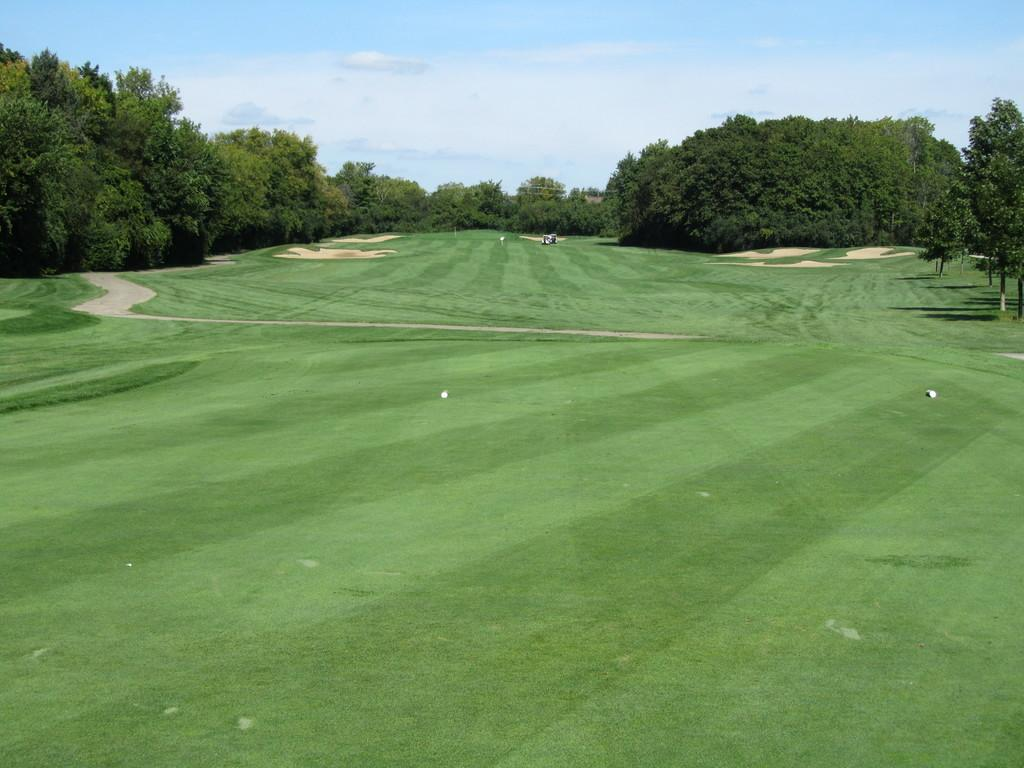What is the primary surface visible in the image? There is a ground in the image. What can be found on the ground in the image? There are objects on the ground. What is the central feature of the image? There is a lane in the center of the image. What type of vegetation is visible at the top of the image? There are trees visible at the top of the image. What is visible above the trees in the image? The sky is visible at the top of the image. What can be seen in the sky in the image? Clouds are present in the sky. What type of wound can be seen on the giant's foot in the image? There are no giants present in the image, so there is no wound to be seen on a giant's foot. What type of shoe is the giant wearing in the image? There are no giants or shoes present in the image. 